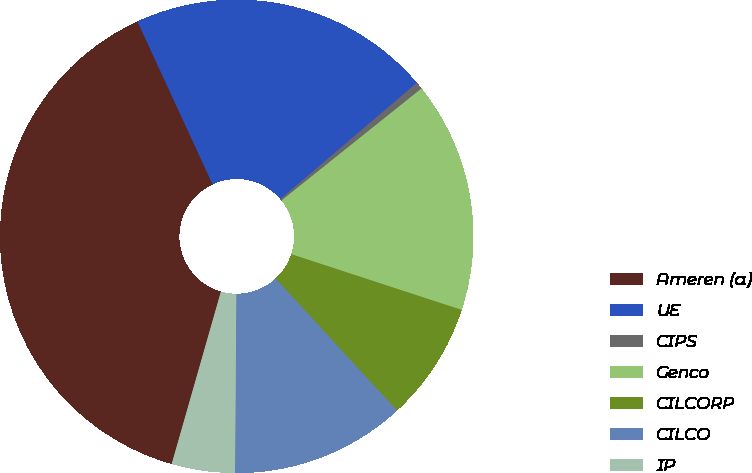Convert chart to OTSL. <chart><loc_0><loc_0><loc_500><loc_500><pie_chart><fcel>Ameren (a)<fcel>UE<fcel>CIPS<fcel>Genco<fcel>CILCORP<fcel>CILCO<fcel>IP<nl><fcel>38.69%<fcel>20.65%<fcel>0.49%<fcel>15.77%<fcel>8.13%<fcel>11.95%<fcel>4.31%<nl></chart> 